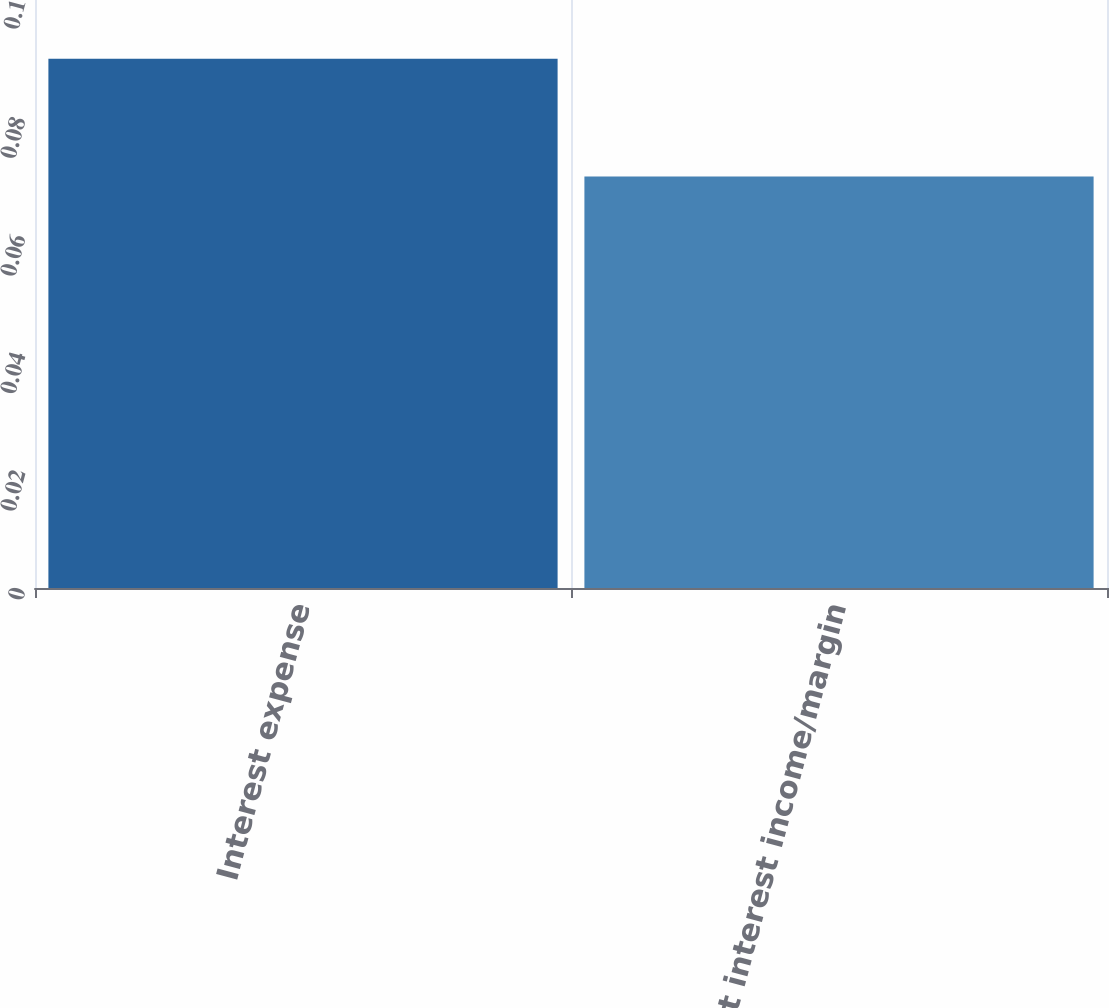Convert chart to OTSL. <chart><loc_0><loc_0><loc_500><loc_500><bar_chart><fcel>Interest expense<fcel>Net interest income/margin<nl><fcel>0.09<fcel>0.07<nl></chart> 